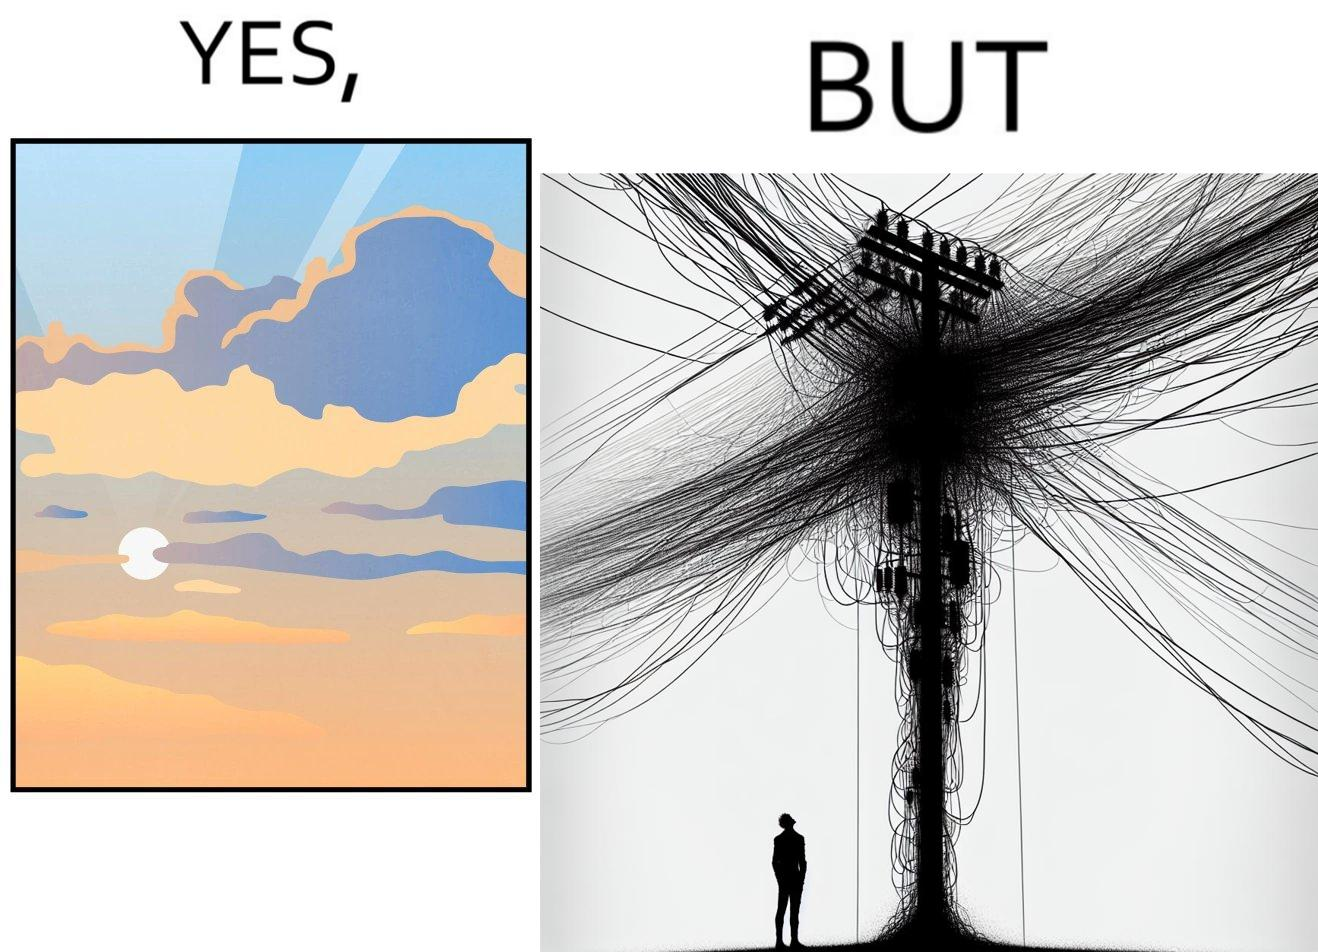Explain why this image is satirical. The image is ironic, because in the first image clear sky is visible but in the second image the same view is getting blocked due to the electricity pole 